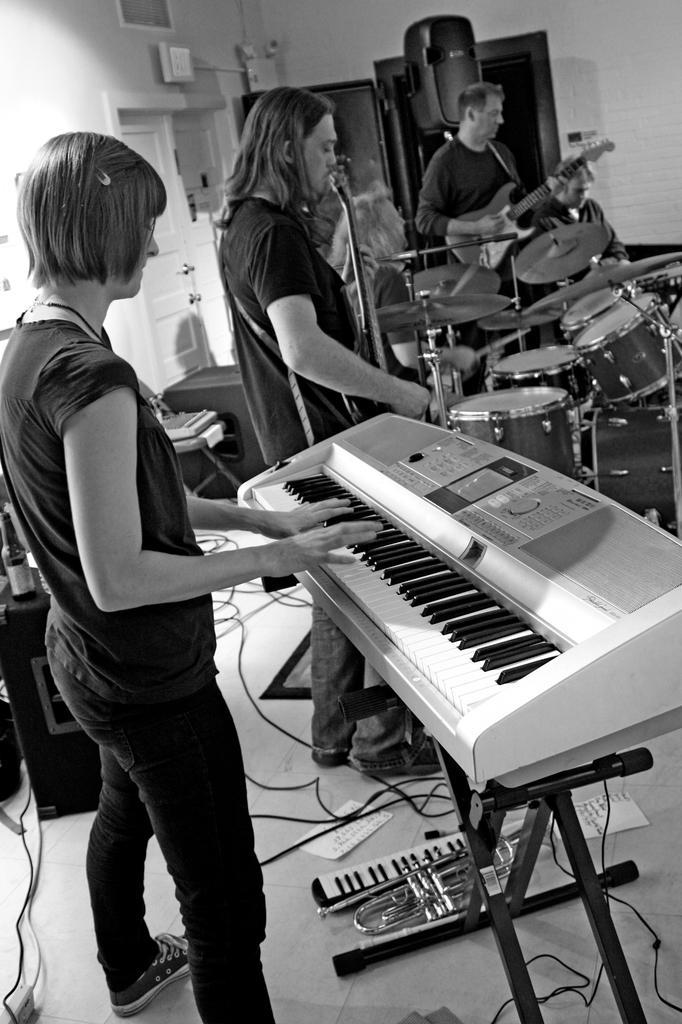Can you describe this image briefly? This is a black and white picture. Here we can see three persons are playing some musical instruments. This is floor. On the background there is a door and this is wall. 